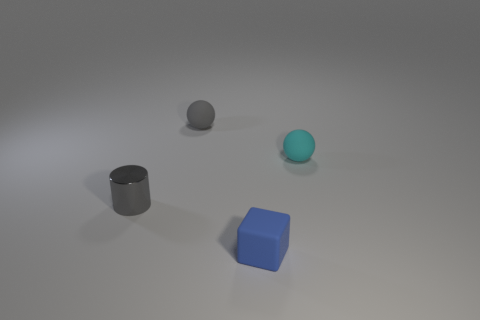Add 2 balls. How many objects exist? 6 Subtract all blocks. How many objects are left? 3 Add 3 cyan rubber things. How many cyan rubber things exist? 4 Subtract 0 blue cylinders. How many objects are left? 4 Subtract all small blue rubber objects. Subtract all tiny cylinders. How many objects are left? 2 Add 3 small gray cylinders. How many small gray cylinders are left? 4 